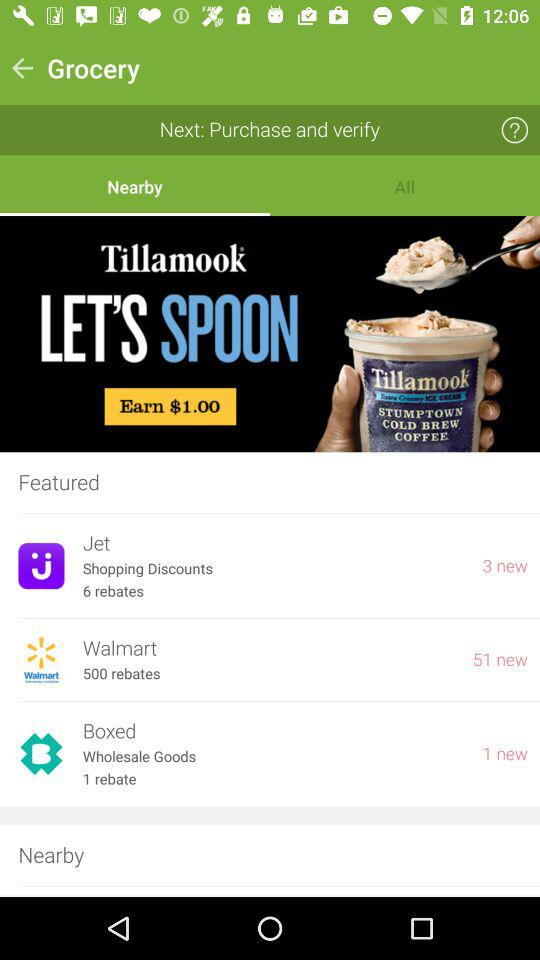How many rebates does the "Boxed" company have? The "Boxed" company has 1 rebate. 